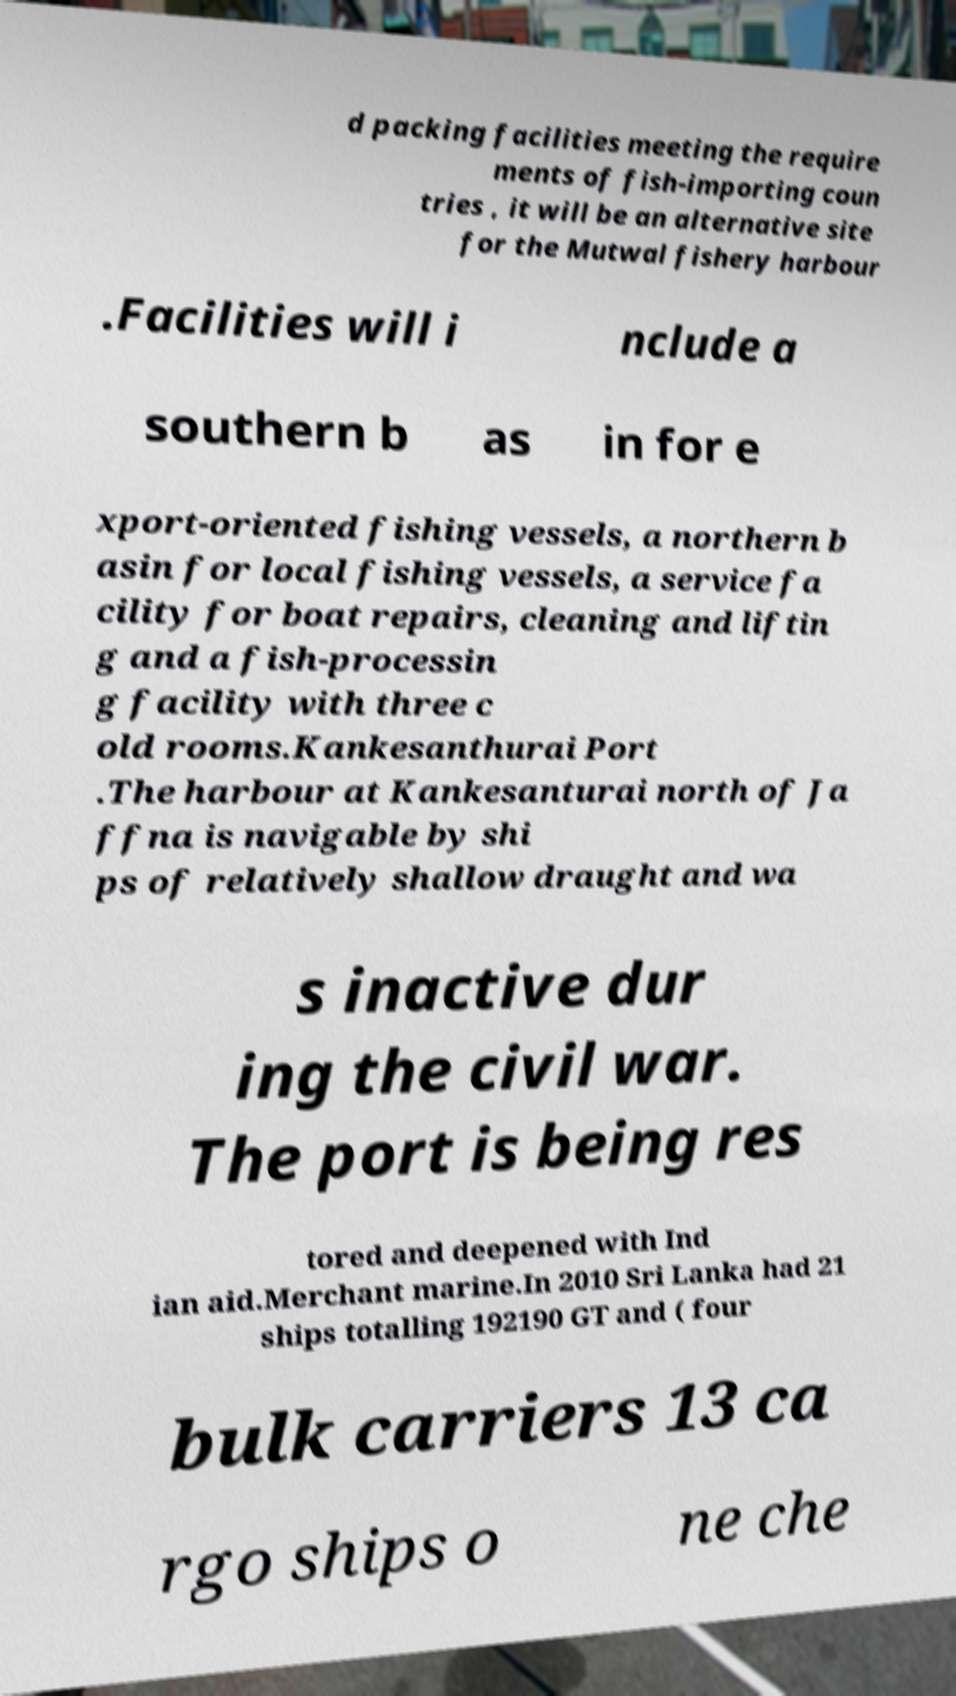Please read and relay the text visible in this image. What does it say? d packing facilities meeting the require ments of fish-importing coun tries , it will be an alternative site for the Mutwal fishery harbour .Facilities will i nclude a southern b as in for e xport-oriented fishing vessels, a northern b asin for local fishing vessels, a service fa cility for boat repairs, cleaning and liftin g and a fish-processin g facility with three c old rooms.Kankesanthurai Port .The harbour at Kankesanturai north of Ja ffna is navigable by shi ps of relatively shallow draught and wa s inactive dur ing the civil war. The port is being res tored and deepened with Ind ian aid.Merchant marine.In 2010 Sri Lanka had 21 ships totalling 192190 GT and ( four bulk carriers 13 ca rgo ships o ne che 